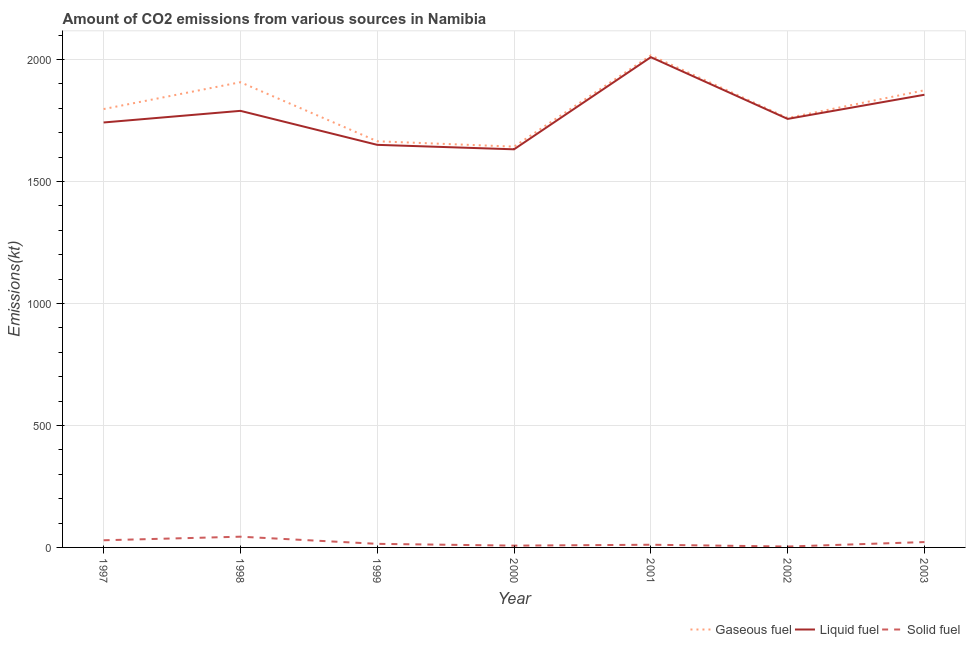How many different coloured lines are there?
Make the answer very short. 3. What is the amount of co2 emissions from gaseous fuel in 2001?
Offer a terse response. 2016.85. Across all years, what is the maximum amount of co2 emissions from liquid fuel?
Make the answer very short. 2009.52. Across all years, what is the minimum amount of co2 emissions from liquid fuel?
Give a very brief answer. 1631.82. In which year was the amount of co2 emissions from gaseous fuel maximum?
Provide a short and direct response. 2001. In which year was the amount of co2 emissions from solid fuel minimum?
Your answer should be compact. 2002. What is the total amount of co2 emissions from liquid fuel in the graph?
Provide a short and direct response. 1.24e+04. What is the difference between the amount of co2 emissions from liquid fuel in 1998 and that in 2001?
Ensure brevity in your answer.  -220.02. What is the difference between the amount of co2 emissions from solid fuel in 2002 and the amount of co2 emissions from liquid fuel in 2000?
Make the answer very short. -1628.15. What is the average amount of co2 emissions from liquid fuel per year?
Ensure brevity in your answer.  1776.4. In the year 1998, what is the difference between the amount of co2 emissions from gaseous fuel and amount of co2 emissions from solid fuel?
Offer a very short reply. 1862.84. In how many years, is the amount of co2 emissions from solid fuel greater than 900 kt?
Offer a terse response. 0. What is the ratio of the amount of co2 emissions from gaseous fuel in 2000 to that in 2002?
Keep it short and to the point. 0.93. Is the difference between the amount of co2 emissions from gaseous fuel in 1998 and 2001 greater than the difference between the amount of co2 emissions from solid fuel in 1998 and 2001?
Your answer should be very brief. No. What is the difference between the highest and the second highest amount of co2 emissions from gaseous fuel?
Your answer should be compact. 110.01. What is the difference between the highest and the lowest amount of co2 emissions from solid fuel?
Make the answer very short. 40.34. In how many years, is the amount of co2 emissions from solid fuel greater than the average amount of co2 emissions from solid fuel taken over all years?
Your response must be concise. 3. Does the amount of co2 emissions from liquid fuel monotonically increase over the years?
Provide a succinct answer. No. What is the difference between two consecutive major ticks on the Y-axis?
Provide a succinct answer. 500. Does the graph contain grids?
Provide a succinct answer. Yes. How many legend labels are there?
Ensure brevity in your answer.  3. How are the legend labels stacked?
Provide a short and direct response. Horizontal. What is the title of the graph?
Make the answer very short. Amount of CO2 emissions from various sources in Namibia. Does "Other sectors" appear as one of the legend labels in the graph?
Your answer should be compact. No. What is the label or title of the X-axis?
Provide a succinct answer. Year. What is the label or title of the Y-axis?
Keep it short and to the point. Emissions(kt). What is the Emissions(kt) in Gaseous fuel in 1997?
Your answer should be compact. 1796.83. What is the Emissions(kt) in Liquid fuel in 1997?
Offer a terse response. 1741.83. What is the Emissions(kt) in Solid fuel in 1997?
Keep it short and to the point. 29.34. What is the Emissions(kt) of Gaseous fuel in 1998?
Ensure brevity in your answer.  1906.84. What is the Emissions(kt) of Liquid fuel in 1998?
Offer a very short reply. 1789.5. What is the Emissions(kt) of Solid fuel in 1998?
Keep it short and to the point. 44. What is the Emissions(kt) of Gaseous fuel in 1999?
Your response must be concise. 1664.82. What is the Emissions(kt) in Liquid fuel in 1999?
Ensure brevity in your answer.  1650.15. What is the Emissions(kt) in Solid fuel in 1999?
Make the answer very short. 14.67. What is the Emissions(kt) in Gaseous fuel in 2000?
Offer a terse response. 1642.82. What is the Emissions(kt) of Liquid fuel in 2000?
Your answer should be very brief. 1631.82. What is the Emissions(kt) in Solid fuel in 2000?
Your answer should be compact. 7.33. What is the Emissions(kt) in Gaseous fuel in 2001?
Ensure brevity in your answer.  2016.85. What is the Emissions(kt) in Liquid fuel in 2001?
Give a very brief answer. 2009.52. What is the Emissions(kt) in Solid fuel in 2001?
Make the answer very short. 11. What is the Emissions(kt) of Gaseous fuel in 2002?
Keep it short and to the point. 1760.16. What is the Emissions(kt) of Liquid fuel in 2002?
Provide a succinct answer. 1756.49. What is the Emissions(kt) in Solid fuel in 2002?
Ensure brevity in your answer.  3.67. What is the Emissions(kt) in Gaseous fuel in 2003?
Give a very brief answer. 1873.84. What is the Emissions(kt) of Liquid fuel in 2003?
Your answer should be compact. 1855.5. What is the Emissions(kt) of Solid fuel in 2003?
Give a very brief answer. 22. Across all years, what is the maximum Emissions(kt) of Gaseous fuel?
Make the answer very short. 2016.85. Across all years, what is the maximum Emissions(kt) of Liquid fuel?
Keep it short and to the point. 2009.52. Across all years, what is the maximum Emissions(kt) of Solid fuel?
Keep it short and to the point. 44. Across all years, what is the minimum Emissions(kt) of Gaseous fuel?
Your response must be concise. 1642.82. Across all years, what is the minimum Emissions(kt) of Liquid fuel?
Provide a short and direct response. 1631.82. Across all years, what is the minimum Emissions(kt) in Solid fuel?
Offer a terse response. 3.67. What is the total Emissions(kt) of Gaseous fuel in the graph?
Your answer should be very brief. 1.27e+04. What is the total Emissions(kt) of Liquid fuel in the graph?
Provide a short and direct response. 1.24e+04. What is the total Emissions(kt) of Solid fuel in the graph?
Offer a very short reply. 132.01. What is the difference between the Emissions(kt) in Gaseous fuel in 1997 and that in 1998?
Keep it short and to the point. -110.01. What is the difference between the Emissions(kt) in Liquid fuel in 1997 and that in 1998?
Your answer should be very brief. -47.67. What is the difference between the Emissions(kt) in Solid fuel in 1997 and that in 1998?
Keep it short and to the point. -14.67. What is the difference between the Emissions(kt) in Gaseous fuel in 1997 and that in 1999?
Provide a short and direct response. 132.01. What is the difference between the Emissions(kt) in Liquid fuel in 1997 and that in 1999?
Your response must be concise. 91.67. What is the difference between the Emissions(kt) of Solid fuel in 1997 and that in 1999?
Give a very brief answer. 14.67. What is the difference between the Emissions(kt) in Gaseous fuel in 1997 and that in 2000?
Your answer should be compact. 154.01. What is the difference between the Emissions(kt) in Liquid fuel in 1997 and that in 2000?
Your answer should be very brief. 110.01. What is the difference between the Emissions(kt) in Solid fuel in 1997 and that in 2000?
Offer a very short reply. 22. What is the difference between the Emissions(kt) of Gaseous fuel in 1997 and that in 2001?
Make the answer very short. -220.02. What is the difference between the Emissions(kt) of Liquid fuel in 1997 and that in 2001?
Give a very brief answer. -267.69. What is the difference between the Emissions(kt) of Solid fuel in 1997 and that in 2001?
Keep it short and to the point. 18.34. What is the difference between the Emissions(kt) in Gaseous fuel in 1997 and that in 2002?
Provide a succinct answer. 36.67. What is the difference between the Emissions(kt) in Liquid fuel in 1997 and that in 2002?
Keep it short and to the point. -14.67. What is the difference between the Emissions(kt) of Solid fuel in 1997 and that in 2002?
Your answer should be compact. 25.67. What is the difference between the Emissions(kt) of Gaseous fuel in 1997 and that in 2003?
Give a very brief answer. -77.01. What is the difference between the Emissions(kt) of Liquid fuel in 1997 and that in 2003?
Provide a succinct answer. -113.68. What is the difference between the Emissions(kt) in Solid fuel in 1997 and that in 2003?
Give a very brief answer. 7.33. What is the difference between the Emissions(kt) of Gaseous fuel in 1998 and that in 1999?
Give a very brief answer. 242.02. What is the difference between the Emissions(kt) of Liquid fuel in 1998 and that in 1999?
Your answer should be very brief. 139.35. What is the difference between the Emissions(kt) of Solid fuel in 1998 and that in 1999?
Offer a terse response. 29.34. What is the difference between the Emissions(kt) of Gaseous fuel in 1998 and that in 2000?
Provide a short and direct response. 264.02. What is the difference between the Emissions(kt) of Liquid fuel in 1998 and that in 2000?
Your response must be concise. 157.68. What is the difference between the Emissions(kt) in Solid fuel in 1998 and that in 2000?
Your answer should be very brief. 36.67. What is the difference between the Emissions(kt) of Gaseous fuel in 1998 and that in 2001?
Make the answer very short. -110.01. What is the difference between the Emissions(kt) of Liquid fuel in 1998 and that in 2001?
Offer a very short reply. -220.02. What is the difference between the Emissions(kt) in Solid fuel in 1998 and that in 2001?
Your answer should be compact. 33. What is the difference between the Emissions(kt) in Gaseous fuel in 1998 and that in 2002?
Your answer should be compact. 146.68. What is the difference between the Emissions(kt) in Liquid fuel in 1998 and that in 2002?
Your answer should be very brief. 33. What is the difference between the Emissions(kt) of Solid fuel in 1998 and that in 2002?
Provide a short and direct response. 40.34. What is the difference between the Emissions(kt) of Gaseous fuel in 1998 and that in 2003?
Your response must be concise. 33. What is the difference between the Emissions(kt) in Liquid fuel in 1998 and that in 2003?
Offer a very short reply. -66.01. What is the difference between the Emissions(kt) in Solid fuel in 1998 and that in 2003?
Provide a succinct answer. 22. What is the difference between the Emissions(kt) of Gaseous fuel in 1999 and that in 2000?
Offer a terse response. 22. What is the difference between the Emissions(kt) of Liquid fuel in 1999 and that in 2000?
Your answer should be compact. 18.34. What is the difference between the Emissions(kt) in Solid fuel in 1999 and that in 2000?
Your response must be concise. 7.33. What is the difference between the Emissions(kt) of Gaseous fuel in 1999 and that in 2001?
Offer a terse response. -352.03. What is the difference between the Emissions(kt) in Liquid fuel in 1999 and that in 2001?
Your answer should be compact. -359.37. What is the difference between the Emissions(kt) in Solid fuel in 1999 and that in 2001?
Ensure brevity in your answer.  3.67. What is the difference between the Emissions(kt) of Gaseous fuel in 1999 and that in 2002?
Provide a short and direct response. -95.34. What is the difference between the Emissions(kt) in Liquid fuel in 1999 and that in 2002?
Your response must be concise. -106.34. What is the difference between the Emissions(kt) of Solid fuel in 1999 and that in 2002?
Give a very brief answer. 11. What is the difference between the Emissions(kt) in Gaseous fuel in 1999 and that in 2003?
Provide a short and direct response. -209.02. What is the difference between the Emissions(kt) in Liquid fuel in 1999 and that in 2003?
Keep it short and to the point. -205.35. What is the difference between the Emissions(kt) in Solid fuel in 1999 and that in 2003?
Your response must be concise. -7.33. What is the difference between the Emissions(kt) in Gaseous fuel in 2000 and that in 2001?
Your answer should be compact. -374.03. What is the difference between the Emissions(kt) of Liquid fuel in 2000 and that in 2001?
Provide a succinct answer. -377.7. What is the difference between the Emissions(kt) of Solid fuel in 2000 and that in 2001?
Your answer should be very brief. -3.67. What is the difference between the Emissions(kt) in Gaseous fuel in 2000 and that in 2002?
Your answer should be very brief. -117.34. What is the difference between the Emissions(kt) of Liquid fuel in 2000 and that in 2002?
Make the answer very short. -124.68. What is the difference between the Emissions(kt) in Solid fuel in 2000 and that in 2002?
Offer a terse response. 3.67. What is the difference between the Emissions(kt) in Gaseous fuel in 2000 and that in 2003?
Provide a short and direct response. -231.02. What is the difference between the Emissions(kt) of Liquid fuel in 2000 and that in 2003?
Your response must be concise. -223.69. What is the difference between the Emissions(kt) in Solid fuel in 2000 and that in 2003?
Make the answer very short. -14.67. What is the difference between the Emissions(kt) in Gaseous fuel in 2001 and that in 2002?
Make the answer very short. 256.69. What is the difference between the Emissions(kt) of Liquid fuel in 2001 and that in 2002?
Your response must be concise. 253.02. What is the difference between the Emissions(kt) of Solid fuel in 2001 and that in 2002?
Provide a succinct answer. 7.33. What is the difference between the Emissions(kt) of Gaseous fuel in 2001 and that in 2003?
Ensure brevity in your answer.  143.01. What is the difference between the Emissions(kt) of Liquid fuel in 2001 and that in 2003?
Your response must be concise. 154.01. What is the difference between the Emissions(kt) in Solid fuel in 2001 and that in 2003?
Your response must be concise. -11. What is the difference between the Emissions(kt) of Gaseous fuel in 2002 and that in 2003?
Ensure brevity in your answer.  -113.68. What is the difference between the Emissions(kt) in Liquid fuel in 2002 and that in 2003?
Keep it short and to the point. -99.01. What is the difference between the Emissions(kt) of Solid fuel in 2002 and that in 2003?
Your answer should be compact. -18.34. What is the difference between the Emissions(kt) in Gaseous fuel in 1997 and the Emissions(kt) in Liquid fuel in 1998?
Your answer should be compact. 7.33. What is the difference between the Emissions(kt) of Gaseous fuel in 1997 and the Emissions(kt) of Solid fuel in 1998?
Provide a short and direct response. 1752.83. What is the difference between the Emissions(kt) of Liquid fuel in 1997 and the Emissions(kt) of Solid fuel in 1998?
Ensure brevity in your answer.  1697.82. What is the difference between the Emissions(kt) in Gaseous fuel in 1997 and the Emissions(kt) in Liquid fuel in 1999?
Keep it short and to the point. 146.68. What is the difference between the Emissions(kt) of Gaseous fuel in 1997 and the Emissions(kt) of Solid fuel in 1999?
Keep it short and to the point. 1782.16. What is the difference between the Emissions(kt) in Liquid fuel in 1997 and the Emissions(kt) in Solid fuel in 1999?
Your answer should be very brief. 1727.16. What is the difference between the Emissions(kt) of Gaseous fuel in 1997 and the Emissions(kt) of Liquid fuel in 2000?
Ensure brevity in your answer.  165.01. What is the difference between the Emissions(kt) in Gaseous fuel in 1997 and the Emissions(kt) in Solid fuel in 2000?
Give a very brief answer. 1789.5. What is the difference between the Emissions(kt) of Liquid fuel in 1997 and the Emissions(kt) of Solid fuel in 2000?
Your response must be concise. 1734.49. What is the difference between the Emissions(kt) of Gaseous fuel in 1997 and the Emissions(kt) of Liquid fuel in 2001?
Provide a succinct answer. -212.69. What is the difference between the Emissions(kt) of Gaseous fuel in 1997 and the Emissions(kt) of Solid fuel in 2001?
Offer a terse response. 1785.83. What is the difference between the Emissions(kt) in Liquid fuel in 1997 and the Emissions(kt) in Solid fuel in 2001?
Your answer should be very brief. 1730.82. What is the difference between the Emissions(kt) in Gaseous fuel in 1997 and the Emissions(kt) in Liquid fuel in 2002?
Make the answer very short. 40.34. What is the difference between the Emissions(kt) in Gaseous fuel in 1997 and the Emissions(kt) in Solid fuel in 2002?
Keep it short and to the point. 1793.16. What is the difference between the Emissions(kt) of Liquid fuel in 1997 and the Emissions(kt) of Solid fuel in 2002?
Your answer should be compact. 1738.16. What is the difference between the Emissions(kt) of Gaseous fuel in 1997 and the Emissions(kt) of Liquid fuel in 2003?
Your answer should be compact. -58.67. What is the difference between the Emissions(kt) of Gaseous fuel in 1997 and the Emissions(kt) of Solid fuel in 2003?
Your answer should be compact. 1774.83. What is the difference between the Emissions(kt) of Liquid fuel in 1997 and the Emissions(kt) of Solid fuel in 2003?
Give a very brief answer. 1719.82. What is the difference between the Emissions(kt) in Gaseous fuel in 1998 and the Emissions(kt) in Liquid fuel in 1999?
Make the answer very short. 256.69. What is the difference between the Emissions(kt) in Gaseous fuel in 1998 and the Emissions(kt) in Solid fuel in 1999?
Keep it short and to the point. 1892.17. What is the difference between the Emissions(kt) of Liquid fuel in 1998 and the Emissions(kt) of Solid fuel in 1999?
Your answer should be very brief. 1774.83. What is the difference between the Emissions(kt) in Gaseous fuel in 1998 and the Emissions(kt) in Liquid fuel in 2000?
Make the answer very short. 275.02. What is the difference between the Emissions(kt) of Gaseous fuel in 1998 and the Emissions(kt) of Solid fuel in 2000?
Your answer should be very brief. 1899.51. What is the difference between the Emissions(kt) in Liquid fuel in 1998 and the Emissions(kt) in Solid fuel in 2000?
Your response must be concise. 1782.16. What is the difference between the Emissions(kt) in Gaseous fuel in 1998 and the Emissions(kt) in Liquid fuel in 2001?
Give a very brief answer. -102.68. What is the difference between the Emissions(kt) in Gaseous fuel in 1998 and the Emissions(kt) in Solid fuel in 2001?
Offer a terse response. 1895.84. What is the difference between the Emissions(kt) of Liquid fuel in 1998 and the Emissions(kt) of Solid fuel in 2001?
Your answer should be compact. 1778.49. What is the difference between the Emissions(kt) in Gaseous fuel in 1998 and the Emissions(kt) in Liquid fuel in 2002?
Ensure brevity in your answer.  150.35. What is the difference between the Emissions(kt) of Gaseous fuel in 1998 and the Emissions(kt) of Solid fuel in 2002?
Provide a succinct answer. 1903.17. What is the difference between the Emissions(kt) in Liquid fuel in 1998 and the Emissions(kt) in Solid fuel in 2002?
Your answer should be compact. 1785.83. What is the difference between the Emissions(kt) of Gaseous fuel in 1998 and the Emissions(kt) of Liquid fuel in 2003?
Provide a succinct answer. 51.34. What is the difference between the Emissions(kt) of Gaseous fuel in 1998 and the Emissions(kt) of Solid fuel in 2003?
Offer a very short reply. 1884.84. What is the difference between the Emissions(kt) in Liquid fuel in 1998 and the Emissions(kt) in Solid fuel in 2003?
Give a very brief answer. 1767.49. What is the difference between the Emissions(kt) of Gaseous fuel in 1999 and the Emissions(kt) of Liquid fuel in 2000?
Ensure brevity in your answer.  33. What is the difference between the Emissions(kt) of Gaseous fuel in 1999 and the Emissions(kt) of Solid fuel in 2000?
Make the answer very short. 1657.48. What is the difference between the Emissions(kt) of Liquid fuel in 1999 and the Emissions(kt) of Solid fuel in 2000?
Your answer should be compact. 1642.82. What is the difference between the Emissions(kt) in Gaseous fuel in 1999 and the Emissions(kt) in Liquid fuel in 2001?
Offer a terse response. -344.7. What is the difference between the Emissions(kt) of Gaseous fuel in 1999 and the Emissions(kt) of Solid fuel in 2001?
Ensure brevity in your answer.  1653.82. What is the difference between the Emissions(kt) in Liquid fuel in 1999 and the Emissions(kt) in Solid fuel in 2001?
Offer a terse response. 1639.15. What is the difference between the Emissions(kt) of Gaseous fuel in 1999 and the Emissions(kt) of Liquid fuel in 2002?
Your answer should be compact. -91.67. What is the difference between the Emissions(kt) in Gaseous fuel in 1999 and the Emissions(kt) in Solid fuel in 2002?
Ensure brevity in your answer.  1661.15. What is the difference between the Emissions(kt) of Liquid fuel in 1999 and the Emissions(kt) of Solid fuel in 2002?
Provide a short and direct response. 1646.48. What is the difference between the Emissions(kt) of Gaseous fuel in 1999 and the Emissions(kt) of Liquid fuel in 2003?
Give a very brief answer. -190.68. What is the difference between the Emissions(kt) of Gaseous fuel in 1999 and the Emissions(kt) of Solid fuel in 2003?
Keep it short and to the point. 1642.82. What is the difference between the Emissions(kt) in Liquid fuel in 1999 and the Emissions(kt) in Solid fuel in 2003?
Keep it short and to the point. 1628.15. What is the difference between the Emissions(kt) of Gaseous fuel in 2000 and the Emissions(kt) of Liquid fuel in 2001?
Provide a succinct answer. -366.7. What is the difference between the Emissions(kt) of Gaseous fuel in 2000 and the Emissions(kt) of Solid fuel in 2001?
Your answer should be compact. 1631.82. What is the difference between the Emissions(kt) of Liquid fuel in 2000 and the Emissions(kt) of Solid fuel in 2001?
Ensure brevity in your answer.  1620.81. What is the difference between the Emissions(kt) of Gaseous fuel in 2000 and the Emissions(kt) of Liquid fuel in 2002?
Your answer should be very brief. -113.68. What is the difference between the Emissions(kt) of Gaseous fuel in 2000 and the Emissions(kt) of Solid fuel in 2002?
Keep it short and to the point. 1639.15. What is the difference between the Emissions(kt) in Liquid fuel in 2000 and the Emissions(kt) in Solid fuel in 2002?
Make the answer very short. 1628.15. What is the difference between the Emissions(kt) of Gaseous fuel in 2000 and the Emissions(kt) of Liquid fuel in 2003?
Ensure brevity in your answer.  -212.69. What is the difference between the Emissions(kt) of Gaseous fuel in 2000 and the Emissions(kt) of Solid fuel in 2003?
Your answer should be compact. 1620.81. What is the difference between the Emissions(kt) of Liquid fuel in 2000 and the Emissions(kt) of Solid fuel in 2003?
Your answer should be very brief. 1609.81. What is the difference between the Emissions(kt) of Gaseous fuel in 2001 and the Emissions(kt) of Liquid fuel in 2002?
Offer a very short reply. 260.36. What is the difference between the Emissions(kt) of Gaseous fuel in 2001 and the Emissions(kt) of Solid fuel in 2002?
Provide a succinct answer. 2013.18. What is the difference between the Emissions(kt) of Liquid fuel in 2001 and the Emissions(kt) of Solid fuel in 2002?
Make the answer very short. 2005.85. What is the difference between the Emissions(kt) in Gaseous fuel in 2001 and the Emissions(kt) in Liquid fuel in 2003?
Offer a very short reply. 161.35. What is the difference between the Emissions(kt) of Gaseous fuel in 2001 and the Emissions(kt) of Solid fuel in 2003?
Make the answer very short. 1994.85. What is the difference between the Emissions(kt) of Liquid fuel in 2001 and the Emissions(kt) of Solid fuel in 2003?
Ensure brevity in your answer.  1987.51. What is the difference between the Emissions(kt) in Gaseous fuel in 2002 and the Emissions(kt) in Liquid fuel in 2003?
Your answer should be very brief. -95.34. What is the difference between the Emissions(kt) in Gaseous fuel in 2002 and the Emissions(kt) in Solid fuel in 2003?
Your answer should be compact. 1738.16. What is the difference between the Emissions(kt) of Liquid fuel in 2002 and the Emissions(kt) of Solid fuel in 2003?
Your response must be concise. 1734.49. What is the average Emissions(kt) in Gaseous fuel per year?
Your answer should be compact. 1808.88. What is the average Emissions(kt) of Liquid fuel per year?
Make the answer very short. 1776.4. What is the average Emissions(kt) of Solid fuel per year?
Your answer should be compact. 18.86. In the year 1997, what is the difference between the Emissions(kt) of Gaseous fuel and Emissions(kt) of Liquid fuel?
Offer a terse response. 55.01. In the year 1997, what is the difference between the Emissions(kt) in Gaseous fuel and Emissions(kt) in Solid fuel?
Provide a succinct answer. 1767.49. In the year 1997, what is the difference between the Emissions(kt) of Liquid fuel and Emissions(kt) of Solid fuel?
Offer a very short reply. 1712.49. In the year 1998, what is the difference between the Emissions(kt) in Gaseous fuel and Emissions(kt) in Liquid fuel?
Your answer should be compact. 117.34. In the year 1998, what is the difference between the Emissions(kt) of Gaseous fuel and Emissions(kt) of Solid fuel?
Provide a short and direct response. 1862.84. In the year 1998, what is the difference between the Emissions(kt) in Liquid fuel and Emissions(kt) in Solid fuel?
Your answer should be compact. 1745.49. In the year 1999, what is the difference between the Emissions(kt) in Gaseous fuel and Emissions(kt) in Liquid fuel?
Your response must be concise. 14.67. In the year 1999, what is the difference between the Emissions(kt) of Gaseous fuel and Emissions(kt) of Solid fuel?
Give a very brief answer. 1650.15. In the year 1999, what is the difference between the Emissions(kt) in Liquid fuel and Emissions(kt) in Solid fuel?
Provide a succinct answer. 1635.48. In the year 2000, what is the difference between the Emissions(kt) of Gaseous fuel and Emissions(kt) of Liquid fuel?
Your answer should be compact. 11. In the year 2000, what is the difference between the Emissions(kt) of Gaseous fuel and Emissions(kt) of Solid fuel?
Provide a short and direct response. 1635.48. In the year 2000, what is the difference between the Emissions(kt) of Liquid fuel and Emissions(kt) of Solid fuel?
Make the answer very short. 1624.48. In the year 2001, what is the difference between the Emissions(kt) in Gaseous fuel and Emissions(kt) in Liquid fuel?
Provide a short and direct response. 7.33. In the year 2001, what is the difference between the Emissions(kt) in Gaseous fuel and Emissions(kt) in Solid fuel?
Make the answer very short. 2005.85. In the year 2001, what is the difference between the Emissions(kt) of Liquid fuel and Emissions(kt) of Solid fuel?
Make the answer very short. 1998.52. In the year 2002, what is the difference between the Emissions(kt) in Gaseous fuel and Emissions(kt) in Liquid fuel?
Your answer should be very brief. 3.67. In the year 2002, what is the difference between the Emissions(kt) in Gaseous fuel and Emissions(kt) in Solid fuel?
Make the answer very short. 1756.49. In the year 2002, what is the difference between the Emissions(kt) of Liquid fuel and Emissions(kt) of Solid fuel?
Ensure brevity in your answer.  1752.83. In the year 2003, what is the difference between the Emissions(kt) of Gaseous fuel and Emissions(kt) of Liquid fuel?
Keep it short and to the point. 18.34. In the year 2003, what is the difference between the Emissions(kt) of Gaseous fuel and Emissions(kt) of Solid fuel?
Ensure brevity in your answer.  1851.84. In the year 2003, what is the difference between the Emissions(kt) in Liquid fuel and Emissions(kt) in Solid fuel?
Offer a terse response. 1833.5. What is the ratio of the Emissions(kt) of Gaseous fuel in 1997 to that in 1998?
Your response must be concise. 0.94. What is the ratio of the Emissions(kt) of Liquid fuel in 1997 to that in 1998?
Ensure brevity in your answer.  0.97. What is the ratio of the Emissions(kt) in Gaseous fuel in 1997 to that in 1999?
Your answer should be very brief. 1.08. What is the ratio of the Emissions(kt) in Liquid fuel in 1997 to that in 1999?
Your answer should be compact. 1.06. What is the ratio of the Emissions(kt) of Gaseous fuel in 1997 to that in 2000?
Keep it short and to the point. 1.09. What is the ratio of the Emissions(kt) of Liquid fuel in 1997 to that in 2000?
Give a very brief answer. 1.07. What is the ratio of the Emissions(kt) in Solid fuel in 1997 to that in 2000?
Provide a succinct answer. 4. What is the ratio of the Emissions(kt) in Gaseous fuel in 1997 to that in 2001?
Your response must be concise. 0.89. What is the ratio of the Emissions(kt) in Liquid fuel in 1997 to that in 2001?
Make the answer very short. 0.87. What is the ratio of the Emissions(kt) of Solid fuel in 1997 to that in 2001?
Your answer should be compact. 2.67. What is the ratio of the Emissions(kt) in Gaseous fuel in 1997 to that in 2002?
Offer a very short reply. 1.02. What is the ratio of the Emissions(kt) in Solid fuel in 1997 to that in 2002?
Offer a terse response. 8. What is the ratio of the Emissions(kt) in Gaseous fuel in 1997 to that in 2003?
Make the answer very short. 0.96. What is the ratio of the Emissions(kt) of Liquid fuel in 1997 to that in 2003?
Your answer should be compact. 0.94. What is the ratio of the Emissions(kt) in Gaseous fuel in 1998 to that in 1999?
Give a very brief answer. 1.15. What is the ratio of the Emissions(kt) in Liquid fuel in 1998 to that in 1999?
Keep it short and to the point. 1.08. What is the ratio of the Emissions(kt) in Solid fuel in 1998 to that in 1999?
Provide a succinct answer. 3. What is the ratio of the Emissions(kt) in Gaseous fuel in 1998 to that in 2000?
Your answer should be compact. 1.16. What is the ratio of the Emissions(kt) of Liquid fuel in 1998 to that in 2000?
Your response must be concise. 1.1. What is the ratio of the Emissions(kt) of Solid fuel in 1998 to that in 2000?
Provide a succinct answer. 6. What is the ratio of the Emissions(kt) in Gaseous fuel in 1998 to that in 2001?
Ensure brevity in your answer.  0.95. What is the ratio of the Emissions(kt) of Liquid fuel in 1998 to that in 2001?
Ensure brevity in your answer.  0.89. What is the ratio of the Emissions(kt) of Gaseous fuel in 1998 to that in 2002?
Keep it short and to the point. 1.08. What is the ratio of the Emissions(kt) in Liquid fuel in 1998 to that in 2002?
Offer a very short reply. 1.02. What is the ratio of the Emissions(kt) of Gaseous fuel in 1998 to that in 2003?
Provide a succinct answer. 1.02. What is the ratio of the Emissions(kt) of Liquid fuel in 1998 to that in 2003?
Ensure brevity in your answer.  0.96. What is the ratio of the Emissions(kt) in Solid fuel in 1998 to that in 2003?
Your response must be concise. 2. What is the ratio of the Emissions(kt) in Gaseous fuel in 1999 to that in 2000?
Your answer should be compact. 1.01. What is the ratio of the Emissions(kt) in Liquid fuel in 1999 to that in 2000?
Your answer should be compact. 1.01. What is the ratio of the Emissions(kt) in Gaseous fuel in 1999 to that in 2001?
Keep it short and to the point. 0.83. What is the ratio of the Emissions(kt) of Liquid fuel in 1999 to that in 2001?
Make the answer very short. 0.82. What is the ratio of the Emissions(kt) of Solid fuel in 1999 to that in 2001?
Make the answer very short. 1.33. What is the ratio of the Emissions(kt) of Gaseous fuel in 1999 to that in 2002?
Offer a very short reply. 0.95. What is the ratio of the Emissions(kt) of Liquid fuel in 1999 to that in 2002?
Offer a very short reply. 0.94. What is the ratio of the Emissions(kt) of Solid fuel in 1999 to that in 2002?
Make the answer very short. 4. What is the ratio of the Emissions(kt) of Gaseous fuel in 1999 to that in 2003?
Your response must be concise. 0.89. What is the ratio of the Emissions(kt) of Liquid fuel in 1999 to that in 2003?
Give a very brief answer. 0.89. What is the ratio of the Emissions(kt) in Solid fuel in 1999 to that in 2003?
Provide a succinct answer. 0.67. What is the ratio of the Emissions(kt) of Gaseous fuel in 2000 to that in 2001?
Offer a very short reply. 0.81. What is the ratio of the Emissions(kt) of Liquid fuel in 2000 to that in 2001?
Make the answer very short. 0.81. What is the ratio of the Emissions(kt) of Solid fuel in 2000 to that in 2001?
Ensure brevity in your answer.  0.67. What is the ratio of the Emissions(kt) of Gaseous fuel in 2000 to that in 2002?
Make the answer very short. 0.93. What is the ratio of the Emissions(kt) in Liquid fuel in 2000 to that in 2002?
Your answer should be compact. 0.93. What is the ratio of the Emissions(kt) of Gaseous fuel in 2000 to that in 2003?
Offer a very short reply. 0.88. What is the ratio of the Emissions(kt) of Liquid fuel in 2000 to that in 2003?
Make the answer very short. 0.88. What is the ratio of the Emissions(kt) of Solid fuel in 2000 to that in 2003?
Offer a terse response. 0.33. What is the ratio of the Emissions(kt) of Gaseous fuel in 2001 to that in 2002?
Provide a short and direct response. 1.15. What is the ratio of the Emissions(kt) in Liquid fuel in 2001 to that in 2002?
Provide a succinct answer. 1.14. What is the ratio of the Emissions(kt) of Solid fuel in 2001 to that in 2002?
Offer a very short reply. 3. What is the ratio of the Emissions(kt) in Gaseous fuel in 2001 to that in 2003?
Offer a very short reply. 1.08. What is the ratio of the Emissions(kt) in Liquid fuel in 2001 to that in 2003?
Offer a very short reply. 1.08. What is the ratio of the Emissions(kt) in Solid fuel in 2001 to that in 2003?
Your answer should be very brief. 0.5. What is the ratio of the Emissions(kt) in Gaseous fuel in 2002 to that in 2003?
Ensure brevity in your answer.  0.94. What is the ratio of the Emissions(kt) in Liquid fuel in 2002 to that in 2003?
Provide a short and direct response. 0.95. What is the difference between the highest and the second highest Emissions(kt) in Gaseous fuel?
Give a very brief answer. 110.01. What is the difference between the highest and the second highest Emissions(kt) in Liquid fuel?
Ensure brevity in your answer.  154.01. What is the difference between the highest and the second highest Emissions(kt) in Solid fuel?
Your answer should be very brief. 14.67. What is the difference between the highest and the lowest Emissions(kt) of Gaseous fuel?
Offer a very short reply. 374.03. What is the difference between the highest and the lowest Emissions(kt) in Liquid fuel?
Ensure brevity in your answer.  377.7. What is the difference between the highest and the lowest Emissions(kt) in Solid fuel?
Your answer should be very brief. 40.34. 